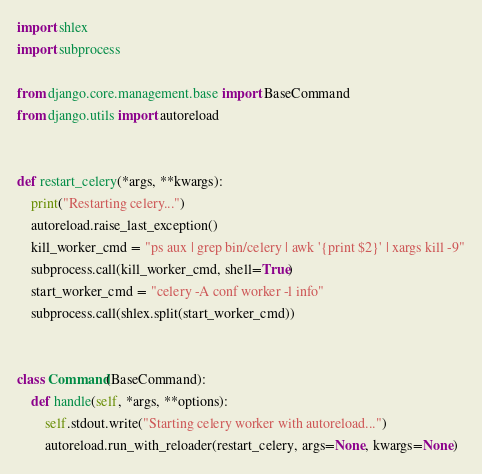Convert code to text. <code><loc_0><loc_0><loc_500><loc_500><_Python_>import shlex
import subprocess

from django.core.management.base import BaseCommand
from django.utils import autoreload


def restart_celery(*args, **kwargs):
    print("Restarting celery...")
    autoreload.raise_last_exception()
    kill_worker_cmd = "ps aux | grep bin/celery | awk '{print $2}' | xargs kill -9"
    subprocess.call(kill_worker_cmd, shell=True)
    start_worker_cmd = "celery -A conf worker -l info"
    subprocess.call(shlex.split(start_worker_cmd))


class Command(BaseCommand):
    def handle(self, *args, **options):
        self.stdout.write("Starting celery worker with autoreload...")
        autoreload.run_with_reloader(restart_celery, args=None, kwargs=None)
</code> 